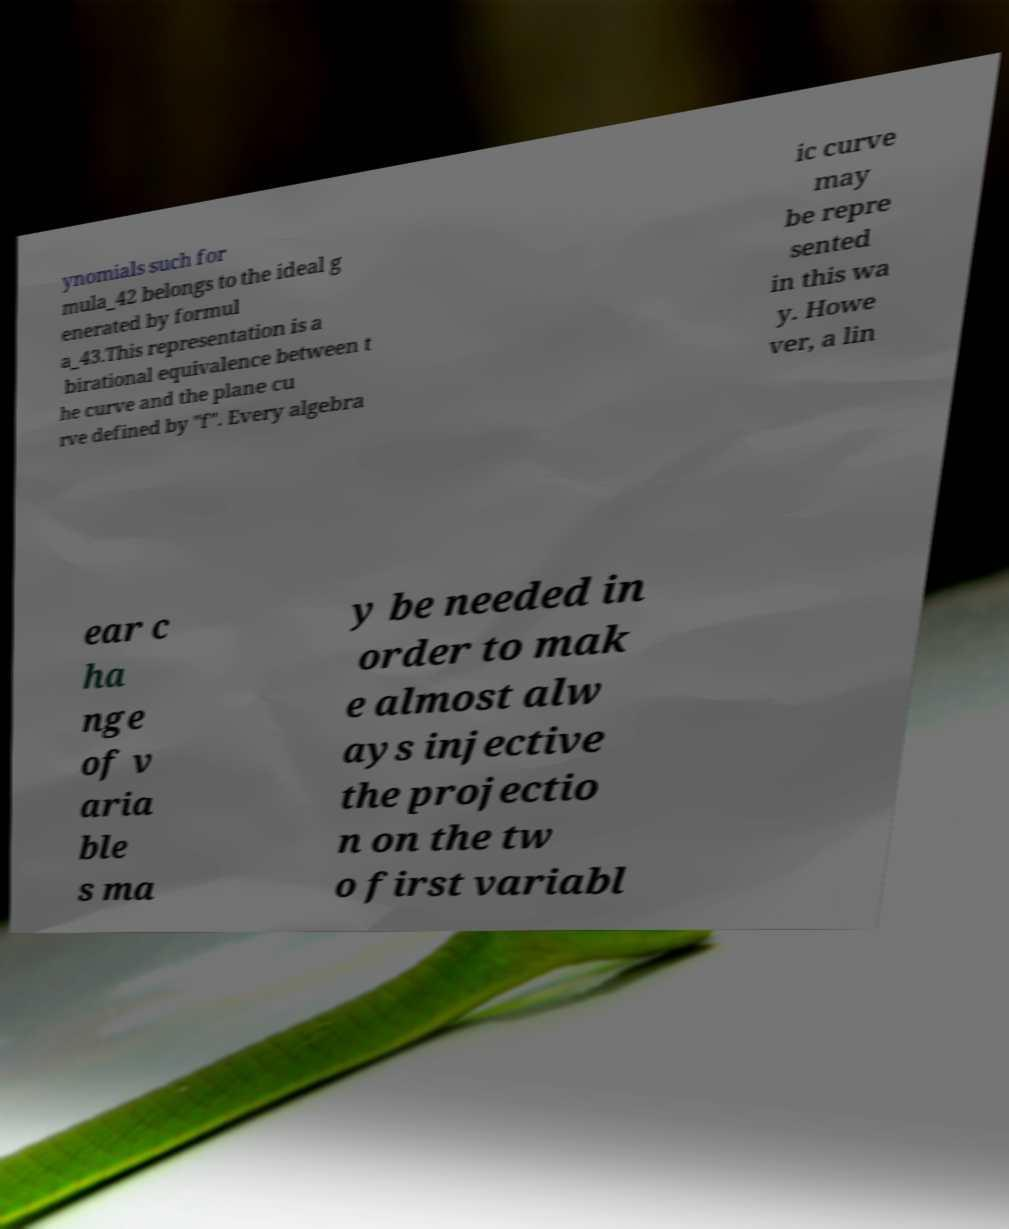Can you read and provide the text displayed in the image?This photo seems to have some interesting text. Can you extract and type it out for me? ynomials such for mula_42 belongs to the ideal g enerated by formul a_43.This representation is a birational equivalence between t he curve and the plane cu rve defined by "f". Every algebra ic curve may be repre sented in this wa y. Howe ver, a lin ear c ha nge of v aria ble s ma y be needed in order to mak e almost alw ays injective the projectio n on the tw o first variabl 